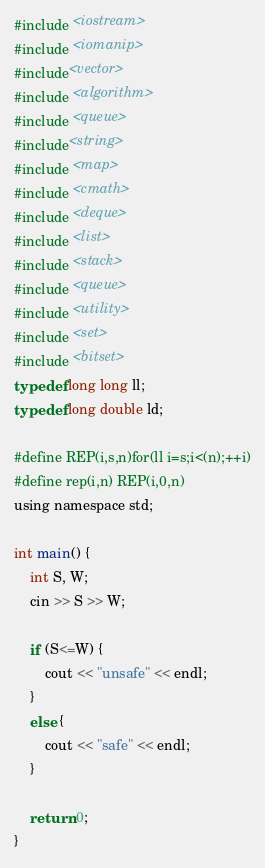Convert code to text. <code><loc_0><loc_0><loc_500><loc_500><_C_>#include <iostream>
#include <iomanip>
#include<vector>
#include <algorithm>
#include <queue>
#include<string>
#include <map>
#include <cmath>
#include <deque>
#include <list>
#include <stack>
#include <queue>
#include <utility>
#include <set>
#include <bitset>
typedef long long ll;
typedef long double ld;

#define REP(i,s,n)for(ll i=s;i<(n);++i)
#define rep(i,n) REP(i,0,n)
using namespace std;

int main() {
    int S, W;
    cin >> S >> W;

    if (S<=W) {
        cout << "unsafe" << endl;
    }
    else {
        cout << "safe" << endl;
    }

    return 0;
}</code> 